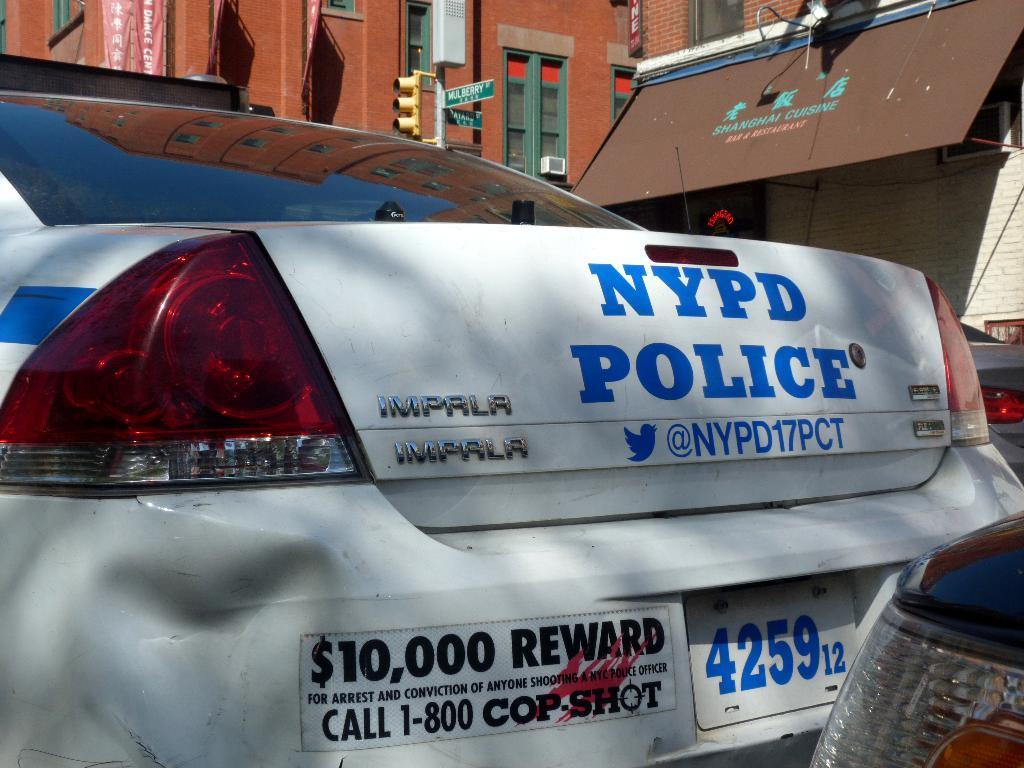Can you describe this image briefly? In this image we can see some cars. On the backside we can see some buildings with windows, a street sign, the traffic signal, a signboard and a banner with some text on them. 